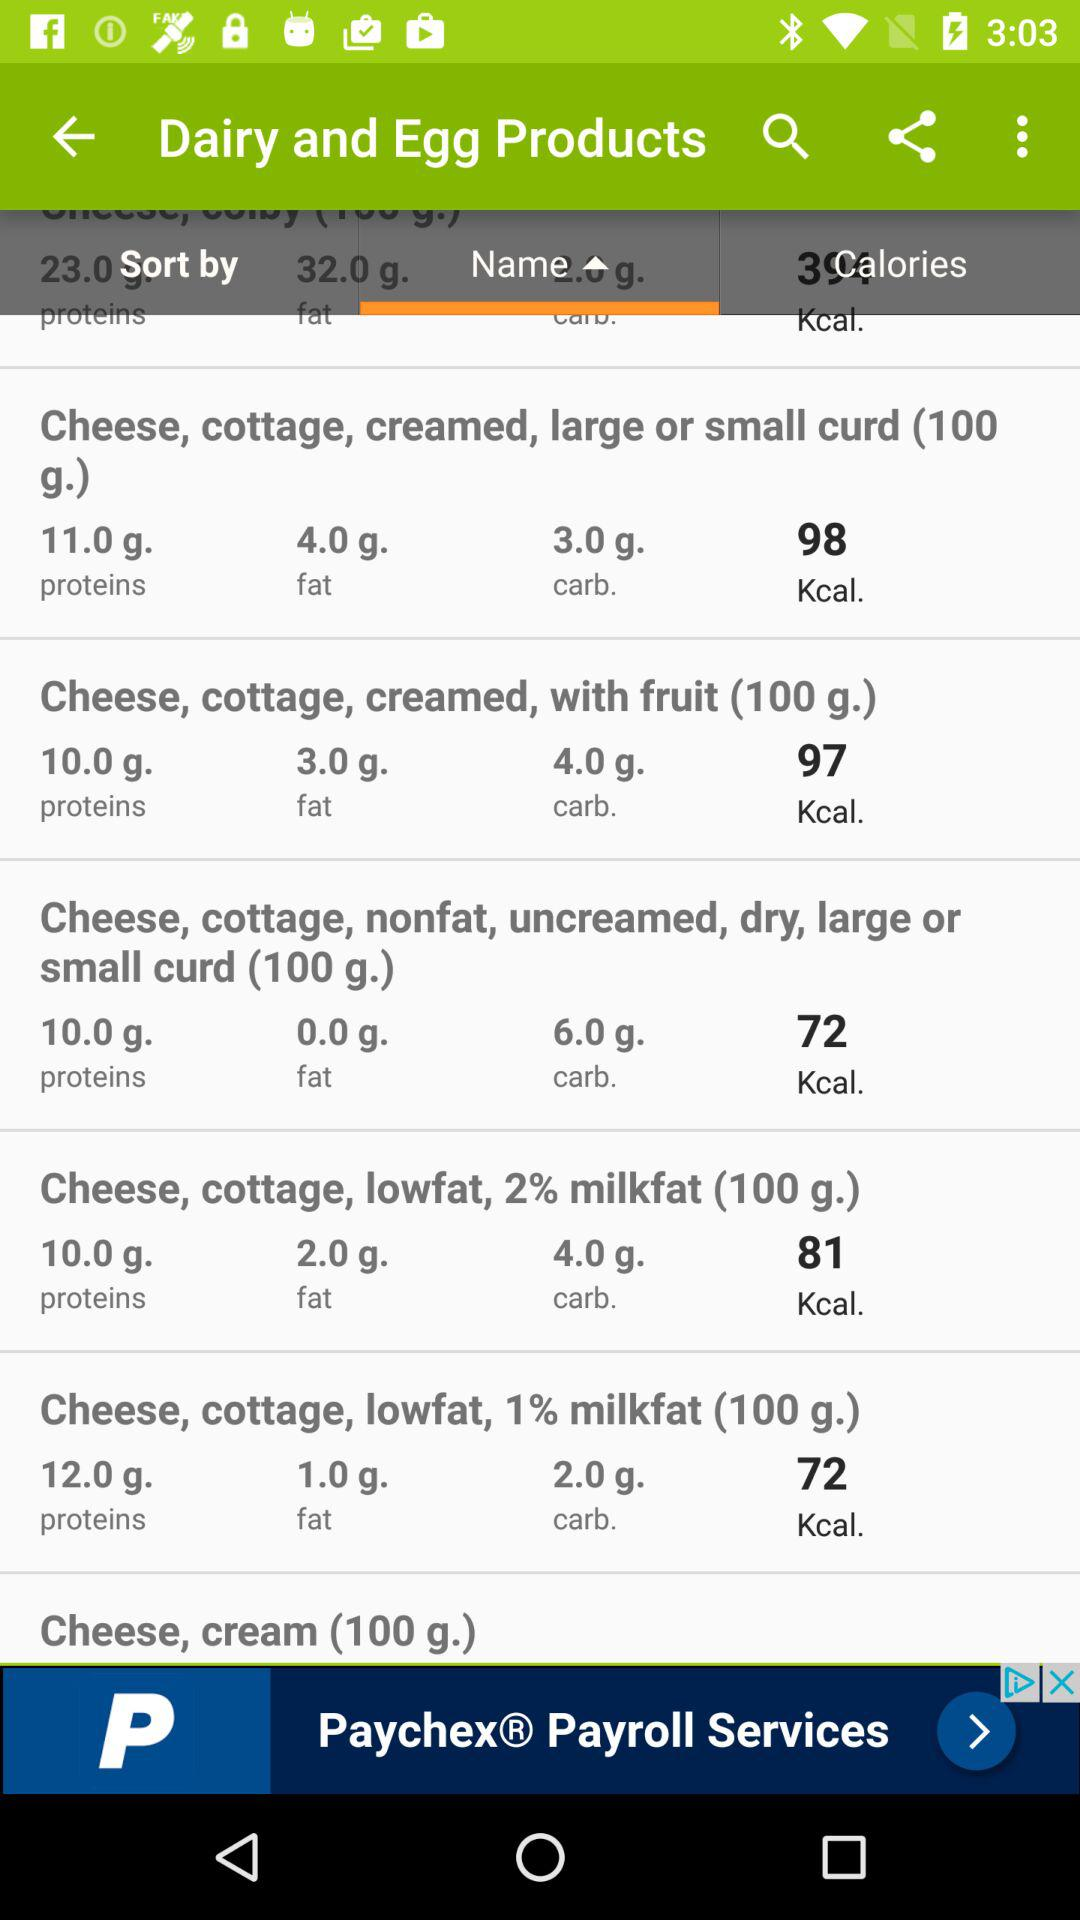How much protein is added to the "Cheese, cottage, creamed, large or small curd(100g.)"? The amount of protein is 11g. 